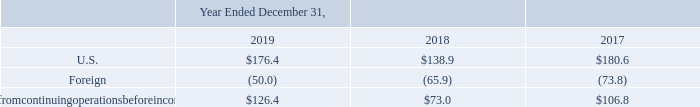Benefit for Income Taxes
Our benefit for income taxes includes U.S. federal, state and foreign income taxes. The domestic and foreign components of our income from continuing operations before income taxes were as follows:
What does benefit for income taxes include? U.s. federal, state and foreign income taxes. What does the table show? The domestic and foreign components of our income from continuing operations before income taxes. Which financial years' information is shown in the table? 2017, 2018, 2019. What is the average U.S. income from continuing operations before income taxes for 2018 and 2019? (176.4+138.9)/2
Answer: 157.65. What is the average U.S. income from continuing operations before income taxes for 2017 and 2018? (138.9+180.6)/2
Answer: 159.75. What is the change in the average U.S. income from continuing operations before income taxes between 2017-2018 and 2018-2019?  [(176.4+138.9)/2] - [(138.9+180.6)/2]
Answer: -2.1. 